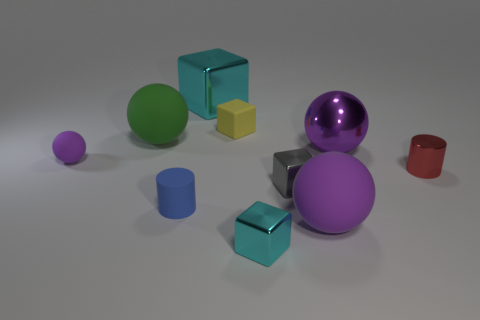There is a large object in front of the small matte sphere; is it the same color as the large metal ball?
Offer a terse response. Yes. Are there any other things that have the same shape as the small cyan object?
Give a very brief answer. Yes. Is there a big rubber object that has the same color as the small matte cylinder?
Ensure brevity in your answer.  No. Is the tiny cylinder behind the blue cylinder made of the same material as the cyan block that is in front of the large cyan cube?
Keep it short and to the point. Yes. The metal cylinder is what color?
Offer a very short reply. Red. There is a cyan shiny cube on the right side of the large metal cube that is on the left side of the tiny object behind the green matte ball; what size is it?
Your answer should be very brief. Small. How many other things are there of the same size as the gray cube?
Keep it short and to the point. 5. How many tiny green cylinders have the same material as the large cyan thing?
Ensure brevity in your answer.  0. There is a rubber object in front of the tiny blue rubber cylinder; what is its shape?
Offer a very short reply. Sphere. Does the large green ball have the same material as the cylinder right of the purple shiny ball?
Offer a terse response. No. 